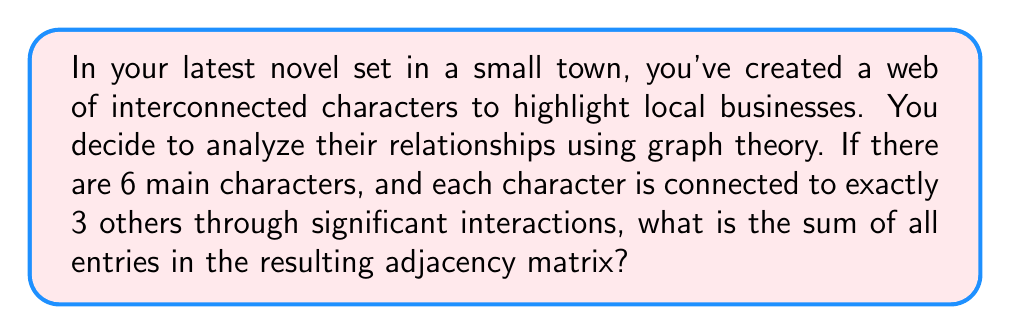Give your solution to this math problem. Let's approach this step-by-step:

1) First, we need to understand what an adjacency matrix is in graph theory. For an undirected graph with n vertices, it's an n × n matrix where:
   - $a_{ij} = 1$ if there's an edge between vertices i and j
   - $a_{ij} = 0$ otherwise

2) In this case, we have 6 characters (vertices) and each character is connected to 3 others.

3) The adjacency matrix A will be a 6 × 6 matrix. 

4) Since each character is connected to 3 others, each row (and column) of the matrix will have exactly 3 ones and 3 zeros.

5) The diagonal of the matrix will be all zeros, as characters are not considered to be connected to themselves.

6) In an undirected graph, the adjacency matrix is symmetric, meaning $a_{ij} = a_{ji}$.

7) To find the sum of all entries, we need to count the total number of ones in the matrix.

8) Each character contributes 3 ones to the matrix. With 6 characters, we might think the total is 6 × 3 = 18.

9) However, this counts each connection twice (once for each character involved). So we need to divide by 2.

10) Therefore, the total number of ones in the matrix is (6 × 3) / 2 = 9.

11) The sum of all entries in the adjacency matrix is equal to the number of ones, which is 9.
Answer: 9 